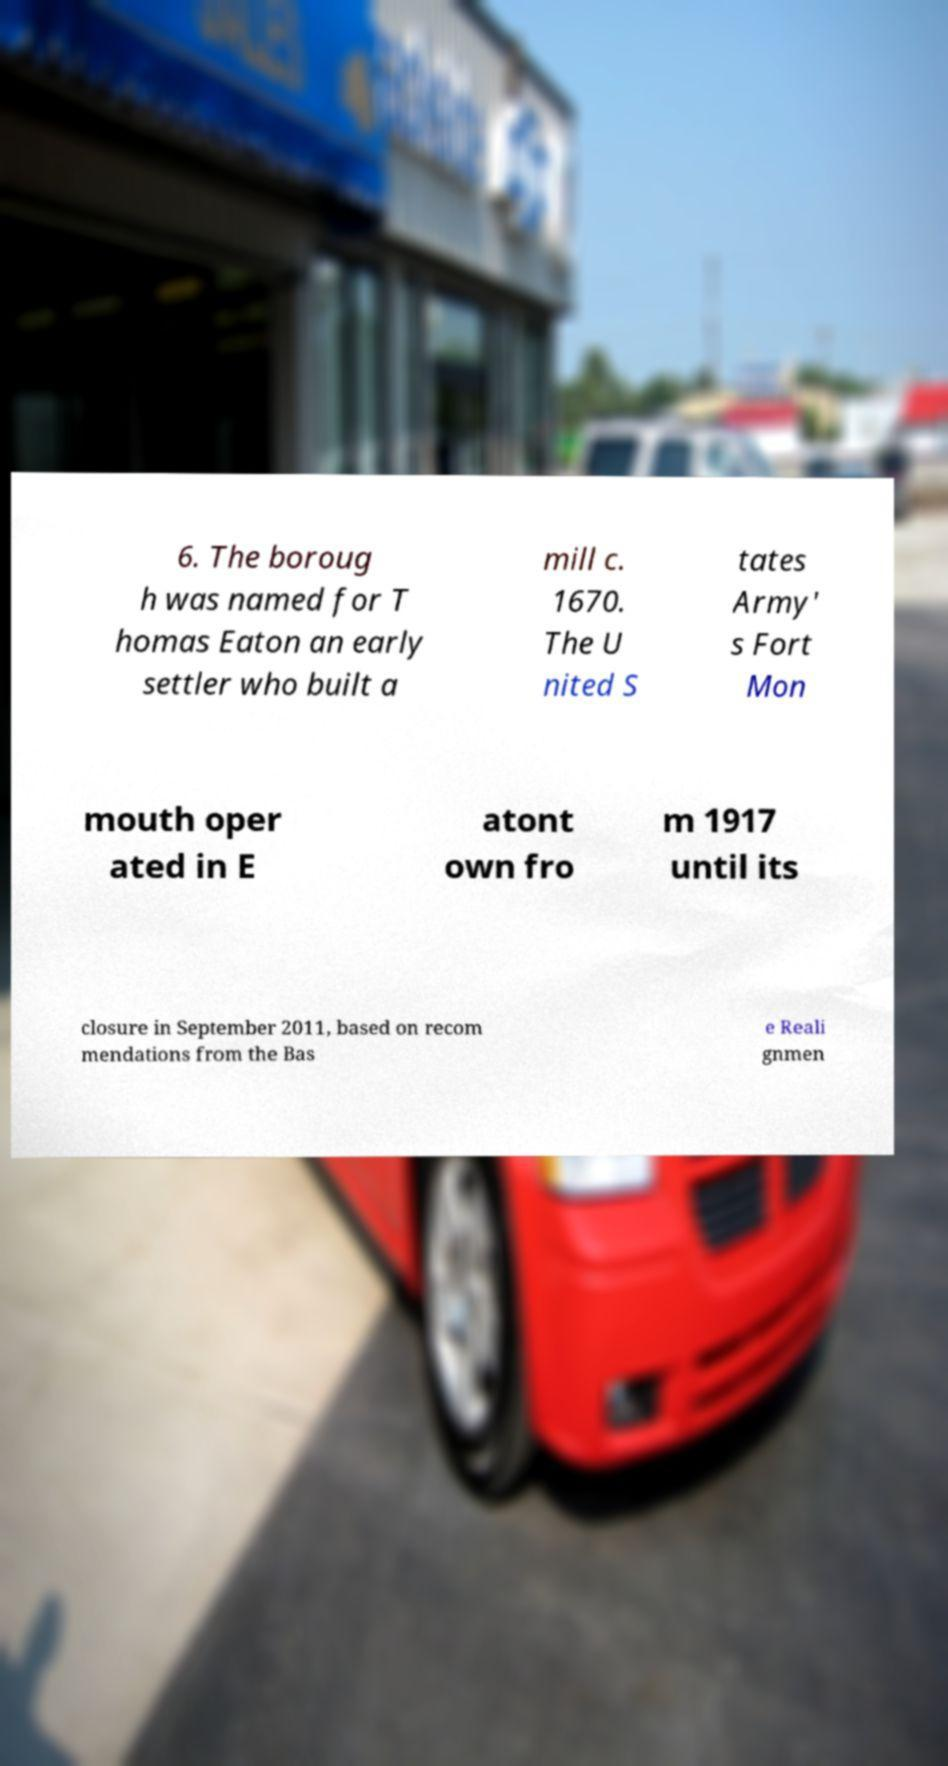Could you extract and type out the text from this image? 6. The boroug h was named for T homas Eaton an early settler who built a mill c. 1670. The U nited S tates Army' s Fort Mon mouth oper ated in E atont own fro m 1917 until its closure in September 2011, based on recom mendations from the Bas e Reali gnmen 